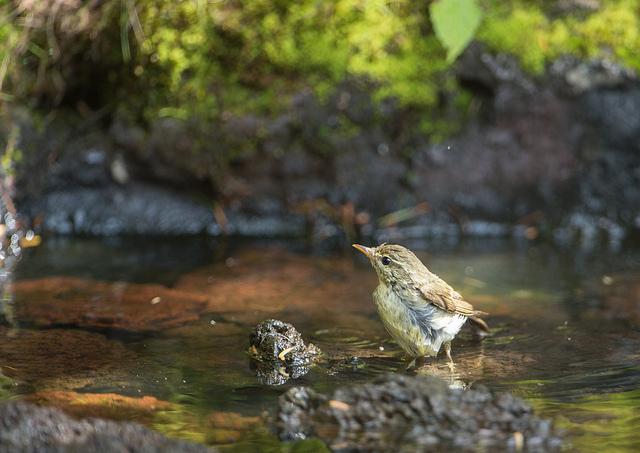What kind of bird is this?
Answer briefly. Sparrow. Can this bird talk?
Write a very short answer. No. What color are the birds eyes?
Short answer required. Black. What type of bird is this?
Answer briefly. Sparrow. What is this bird standing in?
Keep it brief. Water. 